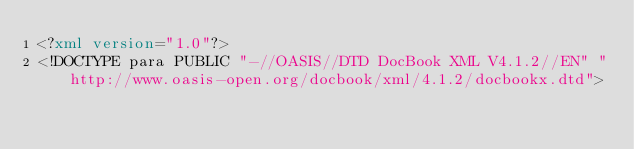Convert code to text. <code><loc_0><loc_0><loc_500><loc_500><_XML_><?xml version="1.0"?>
<!DOCTYPE para PUBLIC "-//OASIS//DTD DocBook XML V4.1.2//EN" "http://www.oasis-open.org/docbook/xml/4.1.2/docbookx.dtd"></code> 